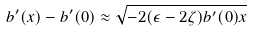Convert formula to latex. <formula><loc_0><loc_0><loc_500><loc_500>b ^ { \prime } ( x ) - b ^ { \prime } ( 0 ) \approx \sqrt { - 2 ( \epsilon - 2 \zeta ) b ^ { \prime } ( 0 ) x }</formula> 